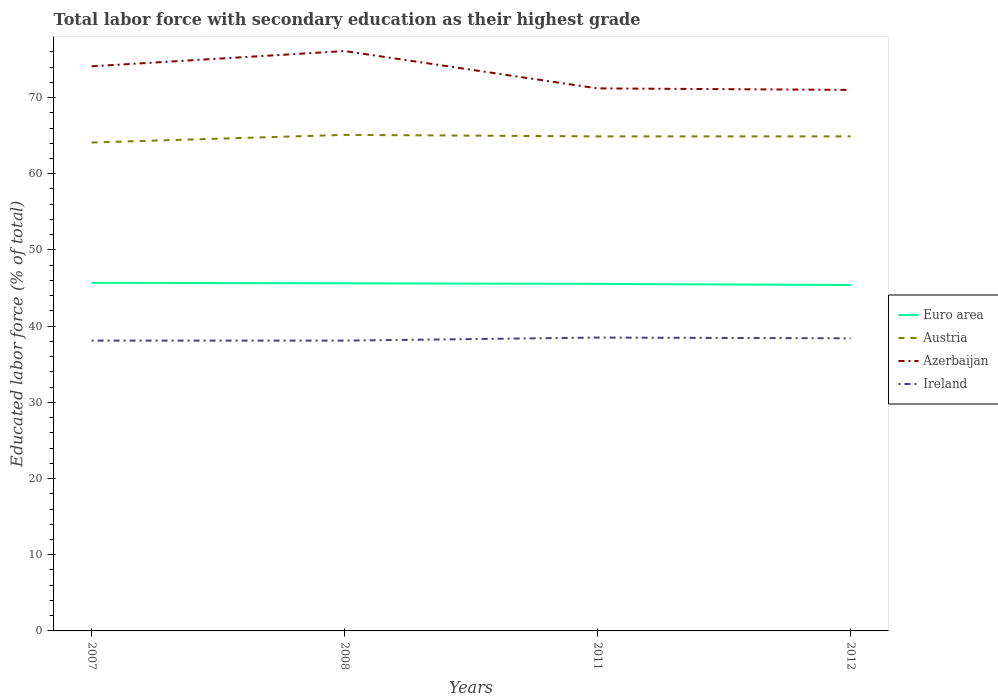Across all years, what is the maximum percentage of total labor force with primary education in Azerbaijan?
Give a very brief answer. 71. What is the total percentage of total labor force with primary education in Ireland in the graph?
Your answer should be very brief. -0.4. What is the difference between the highest and the second highest percentage of total labor force with primary education in Azerbaijan?
Keep it short and to the point. 5.1. How many lines are there?
Offer a terse response. 4. Does the graph contain grids?
Provide a succinct answer. No. Where does the legend appear in the graph?
Make the answer very short. Center right. How many legend labels are there?
Your answer should be compact. 4. How are the legend labels stacked?
Your answer should be compact. Vertical. What is the title of the graph?
Provide a succinct answer. Total labor force with secondary education as their highest grade. Does "Zimbabwe" appear as one of the legend labels in the graph?
Your answer should be compact. No. What is the label or title of the X-axis?
Make the answer very short. Years. What is the label or title of the Y-axis?
Ensure brevity in your answer.  Educated labor force (% of total). What is the Educated labor force (% of total) of Euro area in 2007?
Keep it short and to the point. 45.68. What is the Educated labor force (% of total) in Austria in 2007?
Your answer should be compact. 64.1. What is the Educated labor force (% of total) of Azerbaijan in 2007?
Your answer should be compact. 74.1. What is the Educated labor force (% of total) in Ireland in 2007?
Offer a terse response. 38.1. What is the Educated labor force (% of total) in Euro area in 2008?
Your response must be concise. 45.62. What is the Educated labor force (% of total) in Austria in 2008?
Your response must be concise. 65.1. What is the Educated labor force (% of total) in Azerbaijan in 2008?
Keep it short and to the point. 76.1. What is the Educated labor force (% of total) in Ireland in 2008?
Your answer should be very brief. 38.1. What is the Educated labor force (% of total) of Euro area in 2011?
Provide a short and direct response. 45.54. What is the Educated labor force (% of total) of Austria in 2011?
Offer a very short reply. 64.9. What is the Educated labor force (% of total) in Azerbaijan in 2011?
Your response must be concise. 71.2. What is the Educated labor force (% of total) of Ireland in 2011?
Provide a short and direct response. 38.5. What is the Educated labor force (% of total) of Euro area in 2012?
Provide a short and direct response. 45.39. What is the Educated labor force (% of total) of Austria in 2012?
Ensure brevity in your answer.  64.9. What is the Educated labor force (% of total) of Ireland in 2012?
Your answer should be compact. 38.4. Across all years, what is the maximum Educated labor force (% of total) in Euro area?
Your answer should be compact. 45.68. Across all years, what is the maximum Educated labor force (% of total) in Austria?
Provide a short and direct response. 65.1. Across all years, what is the maximum Educated labor force (% of total) of Azerbaijan?
Your answer should be compact. 76.1. Across all years, what is the maximum Educated labor force (% of total) of Ireland?
Offer a very short reply. 38.5. Across all years, what is the minimum Educated labor force (% of total) in Euro area?
Your answer should be very brief. 45.39. Across all years, what is the minimum Educated labor force (% of total) in Austria?
Provide a succinct answer. 64.1. Across all years, what is the minimum Educated labor force (% of total) in Azerbaijan?
Offer a very short reply. 71. Across all years, what is the minimum Educated labor force (% of total) in Ireland?
Give a very brief answer. 38.1. What is the total Educated labor force (% of total) in Euro area in the graph?
Your answer should be very brief. 182.24. What is the total Educated labor force (% of total) in Austria in the graph?
Ensure brevity in your answer.  259. What is the total Educated labor force (% of total) in Azerbaijan in the graph?
Ensure brevity in your answer.  292.4. What is the total Educated labor force (% of total) in Ireland in the graph?
Your answer should be compact. 153.1. What is the difference between the Educated labor force (% of total) of Euro area in 2007 and that in 2008?
Offer a very short reply. 0.06. What is the difference between the Educated labor force (% of total) of Ireland in 2007 and that in 2008?
Offer a terse response. 0. What is the difference between the Educated labor force (% of total) of Euro area in 2007 and that in 2011?
Keep it short and to the point. 0.14. What is the difference between the Educated labor force (% of total) in Azerbaijan in 2007 and that in 2011?
Ensure brevity in your answer.  2.9. What is the difference between the Educated labor force (% of total) of Euro area in 2007 and that in 2012?
Offer a terse response. 0.29. What is the difference between the Educated labor force (% of total) of Euro area in 2008 and that in 2011?
Ensure brevity in your answer.  0.08. What is the difference between the Educated labor force (% of total) of Austria in 2008 and that in 2011?
Offer a terse response. 0.2. What is the difference between the Educated labor force (% of total) in Azerbaijan in 2008 and that in 2011?
Provide a short and direct response. 4.9. What is the difference between the Educated labor force (% of total) in Euro area in 2008 and that in 2012?
Offer a terse response. 0.23. What is the difference between the Educated labor force (% of total) in Austria in 2008 and that in 2012?
Your answer should be very brief. 0.2. What is the difference between the Educated labor force (% of total) of Azerbaijan in 2008 and that in 2012?
Offer a terse response. 5.1. What is the difference between the Educated labor force (% of total) of Ireland in 2008 and that in 2012?
Your answer should be compact. -0.3. What is the difference between the Educated labor force (% of total) in Euro area in 2011 and that in 2012?
Your answer should be compact. 0.15. What is the difference between the Educated labor force (% of total) of Austria in 2011 and that in 2012?
Ensure brevity in your answer.  0. What is the difference between the Educated labor force (% of total) in Ireland in 2011 and that in 2012?
Ensure brevity in your answer.  0.1. What is the difference between the Educated labor force (% of total) in Euro area in 2007 and the Educated labor force (% of total) in Austria in 2008?
Your answer should be compact. -19.42. What is the difference between the Educated labor force (% of total) of Euro area in 2007 and the Educated labor force (% of total) of Azerbaijan in 2008?
Give a very brief answer. -30.42. What is the difference between the Educated labor force (% of total) of Euro area in 2007 and the Educated labor force (% of total) of Ireland in 2008?
Your response must be concise. 7.58. What is the difference between the Educated labor force (% of total) in Austria in 2007 and the Educated labor force (% of total) in Azerbaijan in 2008?
Your answer should be very brief. -12. What is the difference between the Educated labor force (% of total) in Austria in 2007 and the Educated labor force (% of total) in Ireland in 2008?
Offer a very short reply. 26. What is the difference between the Educated labor force (% of total) in Euro area in 2007 and the Educated labor force (% of total) in Austria in 2011?
Your answer should be compact. -19.22. What is the difference between the Educated labor force (% of total) in Euro area in 2007 and the Educated labor force (% of total) in Azerbaijan in 2011?
Provide a succinct answer. -25.52. What is the difference between the Educated labor force (% of total) in Euro area in 2007 and the Educated labor force (% of total) in Ireland in 2011?
Your response must be concise. 7.18. What is the difference between the Educated labor force (% of total) of Austria in 2007 and the Educated labor force (% of total) of Ireland in 2011?
Your answer should be compact. 25.6. What is the difference between the Educated labor force (% of total) in Azerbaijan in 2007 and the Educated labor force (% of total) in Ireland in 2011?
Provide a succinct answer. 35.6. What is the difference between the Educated labor force (% of total) in Euro area in 2007 and the Educated labor force (% of total) in Austria in 2012?
Your response must be concise. -19.22. What is the difference between the Educated labor force (% of total) in Euro area in 2007 and the Educated labor force (% of total) in Azerbaijan in 2012?
Offer a very short reply. -25.32. What is the difference between the Educated labor force (% of total) of Euro area in 2007 and the Educated labor force (% of total) of Ireland in 2012?
Offer a very short reply. 7.28. What is the difference between the Educated labor force (% of total) in Austria in 2007 and the Educated labor force (% of total) in Ireland in 2012?
Keep it short and to the point. 25.7. What is the difference between the Educated labor force (% of total) in Azerbaijan in 2007 and the Educated labor force (% of total) in Ireland in 2012?
Offer a terse response. 35.7. What is the difference between the Educated labor force (% of total) of Euro area in 2008 and the Educated labor force (% of total) of Austria in 2011?
Make the answer very short. -19.28. What is the difference between the Educated labor force (% of total) in Euro area in 2008 and the Educated labor force (% of total) in Azerbaijan in 2011?
Ensure brevity in your answer.  -25.58. What is the difference between the Educated labor force (% of total) of Euro area in 2008 and the Educated labor force (% of total) of Ireland in 2011?
Offer a very short reply. 7.12. What is the difference between the Educated labor force (% of total) of Austria in 2008 and the Educated labor force (% of total) of Azerbaijan in 2011?
Keep it short and to the point. -6.1. What is the difference between the Educated labor force (% of total) of Austria in 2008 and the Educated labor force (% of total) of Ireland in 2011?
Give a very brief answer. 26.6. What is the difference between the Educated labor force (% of total) of Azerbaijan in 2008 and the Educated labor force (% of total) of Ireland in 2011?
Keep it short and to the point. 37.6. What is the difference between the Educated labor force (% of total) in Euro area in 2008 and the Educated labor force (% of total) in Austria in 2012?
Ensure brevity in your answer.  -19.28. What is the difference between the Educated labor force (% of total) of Euro area in 2008 and the Educated labor force (% of total) of Azerbaijan in 2012?
Ensure brevity in your answer.  -25.38. What is the difference between the Educated labor force (% of total) in Euro area in 2008 and the Educated labor force (% of total) in Ireland in 2012?
Keep it short and to the point. 7.22. What is the difference between the Educated labor force (% of total) of Austria in 2008 and the Educated labor force (% of total) of Azerbaijan in 2012?
Give a very brief answer. -5.9. What is the difference between the Educated labor force (% of total) of Austria in 2008 and the Educated labor force (% of total) of Ireland in 2012?
Your answer should be very brief. 26.7. What is the difference between the Educated labor force (% of total) in Azerbaijan in 2008 and the Educated labor force (% of total) in Ireland in 2012?
Offer a very short reply. 37.7. What is the difference between the Educated labor force (% of total) of Euro area in 2011 and the Educated labor force (% of total) of Austria in 2012?
Provide a succinct answer. -19.36. What is the difference between the Educated labor force (% of total) in Euro area in 2011 and the Educated labor force (% of total) in Azerbaijan in 2012?
Ensure brevity in your answer.  -25.46. What is the difference between the Educated labor force (% of total) of Euro area in 2011 and the Educated labor force (% of total) of Ireland in 2012?
Give a very brief answer. 7.14. What is the difference between the Educated labor force (% of total) of Austria in 2011 and the Educated labor force (% of total) of Azerbaijan in 2012?
Provide a short and direct response. -6.1. What is the difference between the Educated labor force (% of total) of Azerbaijan in 2011 and the Educated labor force (% of total) of Ireland in 2012?
Ensure brevity in your answer.  32.8. What is the average Educated labor force (% of total) in Euro area per year?
Ensure brevity in your answer.  45.56. What is the average Educated labor force (% of total) in Austria per year?
Ensure brevity in your answer.  64.75. What is the average Educated labor force (% of total) of Azerbaijan per year?
Keep it short and to the point. 73.1. What is the average Educated labor force (% of total) in Ireland per year?
Your answer should be compact. 38.27. In the year 2007, what is the difference between the Educated labor force (% of total) of Euro area and Educated labor force (% of total) of Austria?
Make the answer very short. -18.42. In the year 2007, what is the difference between the Educated labor force (% of total) in Euro area and Educated labor force (% of total) in Azerbaijan?
Your answer should be compact. -28.42. In the year 2007, what is the difference between the Educated labor force (% of total) of Euro area and Educated labor force (% of total) of Ireland?
Your answer should be compact. 7.58. In the year 2007, what is the difference between the Educated labor force (% of total) of Austria and Educated labor force (% of total) of Azerbaijan?
Provide a short and direct response. -10. In the year 2007, what is the difference between the Educated labor force (% of total) in Austria and Educated labor force (% of total) in Ireland?
Provide a succinct answer. 26. In the year 2007, what is the difference between the Educated labor force (% of total) of Azerbaijan and Educated labor force (% of total) of Ireland?
Your response must be concise. 36. In the year 2008, what is the difference between the Educated labor force (% of total) of Euro area and Educated labor force (% of total) of Austria?
Ensure brevity in your answer.  -19.48. In the year 2008, what is the difference between the Educated labor force (% of total) of Euro area and Educated labor force (% of total) of Azerbaijan?
Provide a succinct answer. -30.48. In the year 2008, what is the difference between the Educated labor force (% of total) of Euro area and Educated labor force (% of total) of Ireland?
Give a very brief answer. 7.52. In the year 2008, what is the difference between the Educated labor force (% of total) of Austria and Educated labor force (% of total) of Azerbaijan?
Provide a short and direct response. -11. In the year 2011, what is the difference between the Educated labor force (% of total) in Euro area and Educated labor force (% of total) in Austria?
Your response must be concise. -19.36. In the year 2011, what is the difference between the Educated labor force (% of total) in Euro area and Educated labor force (% of total) in Azerbaijan?
Your answer should be compact. -25.66. In the year 2011, what is the difference between the Educated labor force (% of total) of Euro area and Educated labor force (% of total) of Ireland?
Keep it short and to the point. 7.04. In the year 2011, what is the difference between the Educated labor force (% of total) of Austria and Educated labor force (% of total) of Ireland?
Your answer should be compact. 26.4. In the year 2011, what is the difference between the Educated labor force (% of total) in Azerbaijan and Educated labor force (% of total) in Ireland?
Offer a terse response. 32.7. In the year 2012, what is the difference between the Educated labor force (% of total) in Euro area and Educated labor force (% of total) in Austria?
Offer a terse response. -19.51. In the year 2012, what is the difference between the Educated labor force (% of total) in Euro area and Educated labor force (% of total) in Azerbaijan?
Ensure brevity in your answer.  -25.61. In the year 2012, what is the difference between the Educated labor force (% of total) in Euro area and Educated labor force (% of total) in Ireland?
Offer a very short reply. 6.99. In the year 2012, what is the difference between the Educated labor force (% of total) in Austria and Educated labor force (% of total) in Azerbaijan?
Provide a succinct answer. -6.1. In the year 2012, what is the difference between the Educated labor force (% of total) of Azerbaijan and Educated labor force (% of total) of Ireland?
Your response must be concise. 32.6. What is the ratio of the Educated labor force (% of total) of Austria in 2007 to that in 2008?
Your answer should be compact. 0.98. What is the ratio of the Educated labor force (% of total) of Azerbaijan in 2007 to that in 2008?
Keep it short and to the point. 0.97. What is the ratio of the Educated labor force (% of total) in Ireland in 2007 to that in 2008?
Your answer should be compact. 1. What is the ratio of the Educated labor force (% of total) in Azerbaijan in 2007 to that in 2011?
Ensure brevity in your answer.  1.04. What is the ratio of the Educated labor force (% of total) in Ireland in 2007 to that in 2011?
Give a very brief answer. 0.99. What is the ratio of the Educated labor force (% of total) in Euro area in 2007 to that in 2012?
Your answer should be compact. 1.01. What is the ratio of the Educated labor force (% of total) of Azerbaijan in 2007 to that in 2012?
Your answer should be compact. 1.04. What is the ratio of the Educated labor force (% of total) of Ireland in 2007 to that in 2012?
Ensure brevity in your answer.  0.99. What is the ratio of the Educated labor force (% of total) in Austria in 2008 to that in 2011?
Provide a succinct answer. 1. What is the ratio of the Educated labor force (% of total) of Azerbaijan in 2008 to that in 2011?
Offer a terse response. 1.07. What is the ratio of the Educated labor force (% of total) of Ireland in 2008 to that in 2011?
Your response must be concise. 0.99. What is the ratio of the Educated labor force (% of total) of Euro area in 2008 to that in 2012?
Your answer should be very brief. 1. What is the ratio of the Educated labor force (% of total) of Azerbaijan in 2008 to that in 2012?
Keep it short and to the point. 1.07. What is the ratio of the Educated labor force (% of total) of Euro area in 2011 to that in 2012?
Your answer should be compact. 1. What is the ratio of the Educated labor force (% of total) in Azerbaijan in 2011 to that in 2012?
Offer a terse response. 1. What is the difference between the highest and the second highest Educated labor force (% of total) of Euro area?
Make the answer very short. 0.06. What is the difference between the highest and the second highest Educated labor force (% of total) in Austria?
Make the answer very short. 0.2. What is the difference between the highest and the second highest Educated labor force (% of total) of Azerbaijan?
Ensure brevity in your answer.  2. What is the difference between the highest and the second highest Educated labor force (% of total) in Ireland?
Give a very brief answer. 0.1. What is the difference between the highest and the lowest Educated labor force (% of total) in Euro area?
Keep it short and to the point. 0.29. What is the difference between the highest and the lowest Educated labor force (% of total) in Ireland?
Keep it short and to the point. 0.4. 